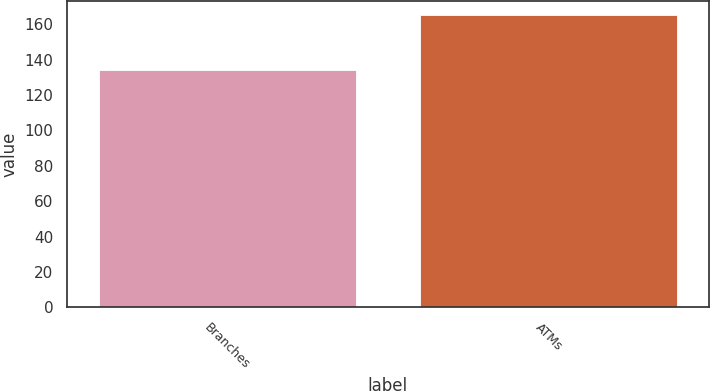Convert chart to OTSL. <chart><loc_0><loc_0><loc_500><loc_500><bar_chart><fcel>Branches<fcel>ATMs<nl><fcel>134<fcel>165<nl></chart> 